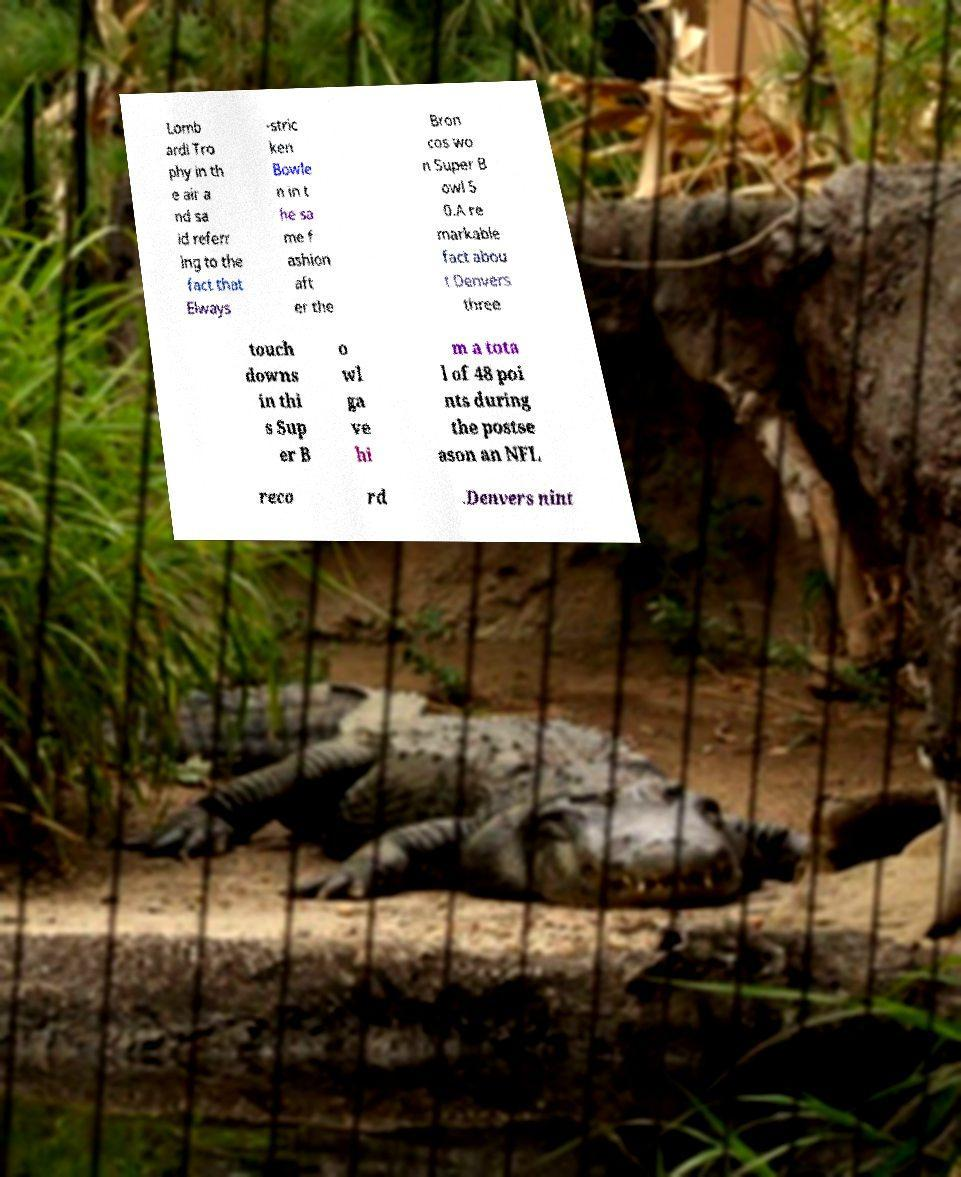I need the written content from this picture converted into text. Can you do that? Lomb ardi Tro phy in th e air a nd sa id referr ing to the fact that Elways -stric ken Bowle n in t he sa me f ashion aft er the Bron cos wo n Super B owl 5 0.A re markable fact abou t Denvers three touch downs in thi s Sup er B o wl ga ve hi m a tota l of 48 poi nts during the postse ason an NFL reco rd .Denvers nint 